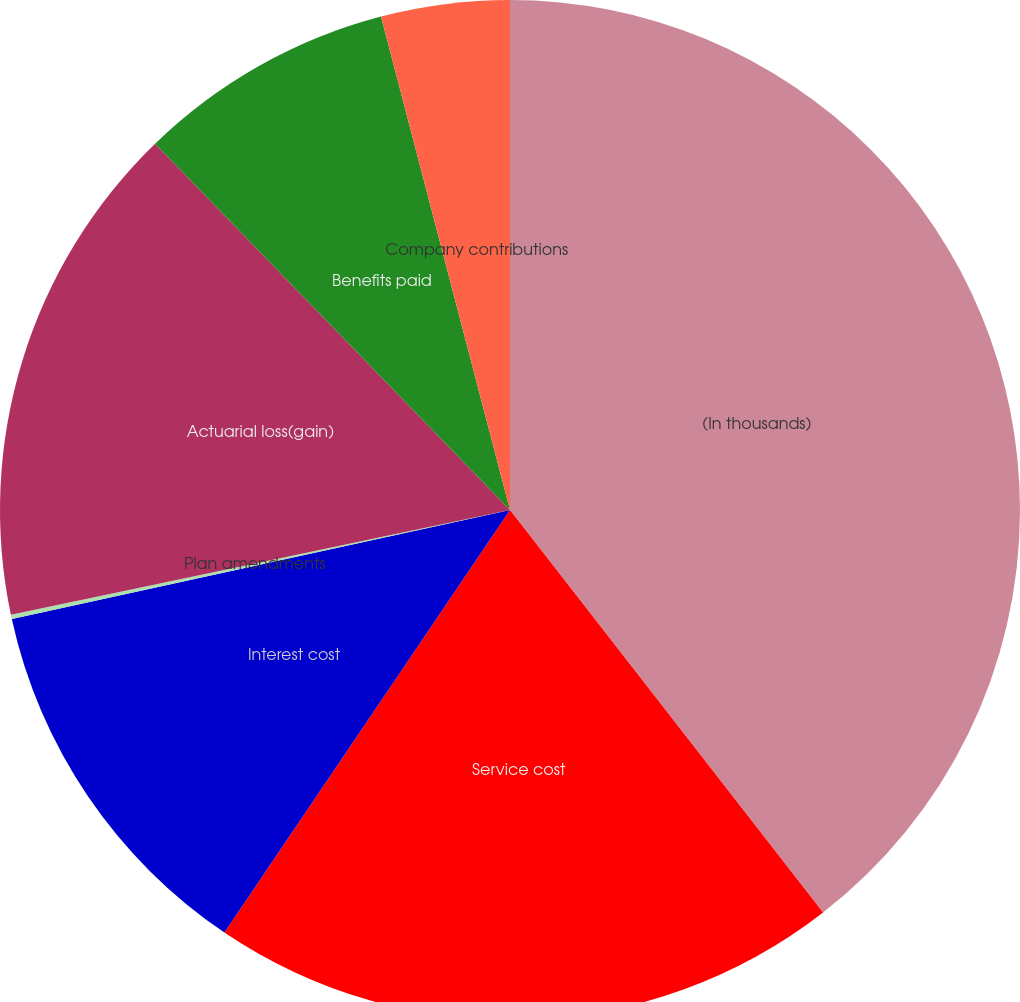<chart> <loc_0><loc_0><loc_500><loc_500><pie_chart><fcel>(In thousands)<fcel>Service cost<fcel>Interest cost<fcel>Plan amendments<fcel>Actuarial loss(gain)<fcel>Benefits paid<fcel>Company contributions<nl><fcel>39.48%<fcel>19.98%<fcel>12.11%<fcel>0.14%<fcel>16.04%<fcel>8.18%<fcel>4.07%<nl></chart> 